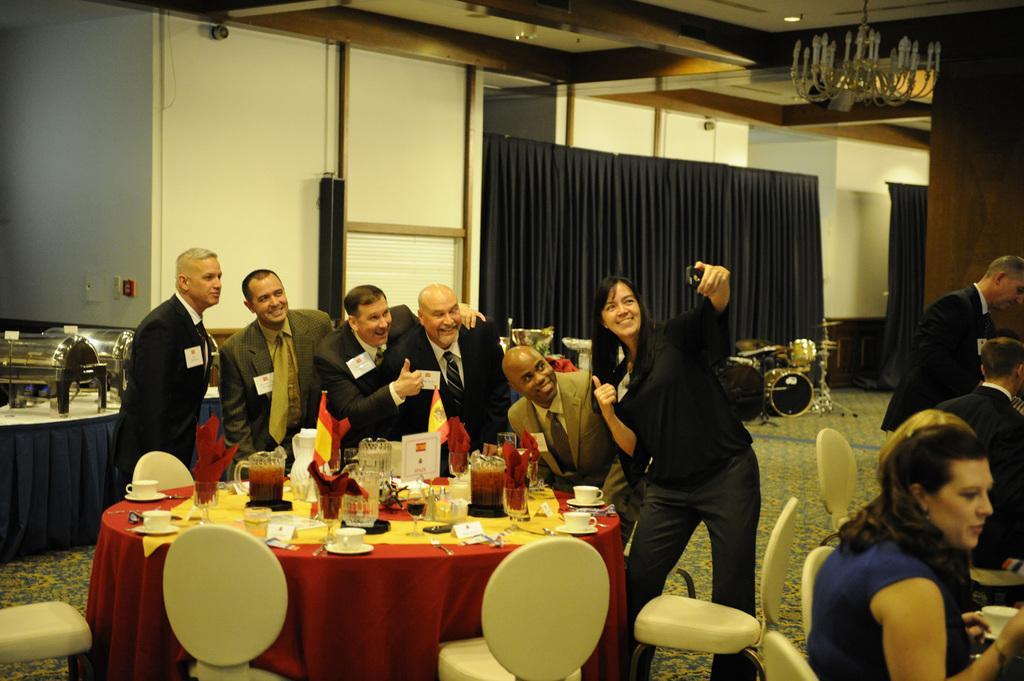In one or two sentences, can you explain what this image depicts? This is the picture taken in a room, there are group of people standing on a floor. In front of this people there is a table on top[of the table there are cup, saucer, jar, flag, spoon and a board. Background of this people is a wall with curtain. 